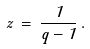<formula> <loc_0><loc_0><loc_500><loc_500>z \, = \, \frac { 1 } { q - 1 } \, .</formula> 